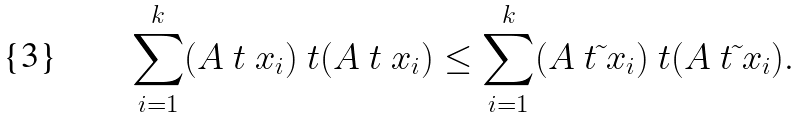Convert formula to latex. <formula><loc_0><loc_0><loc_500><loc_500>\sum _ { i = 1 } ^ { k } ( A \ t \ x _ { i } ) \ t ( A \ t \ x _ { i } ) \leq \sum _ { i = 1 } ^ { k } ( A \ t \tilde { \ } x _ { i } ) \ t ( A \ t \tilde { \ } x _ { i } ) .</formula> 